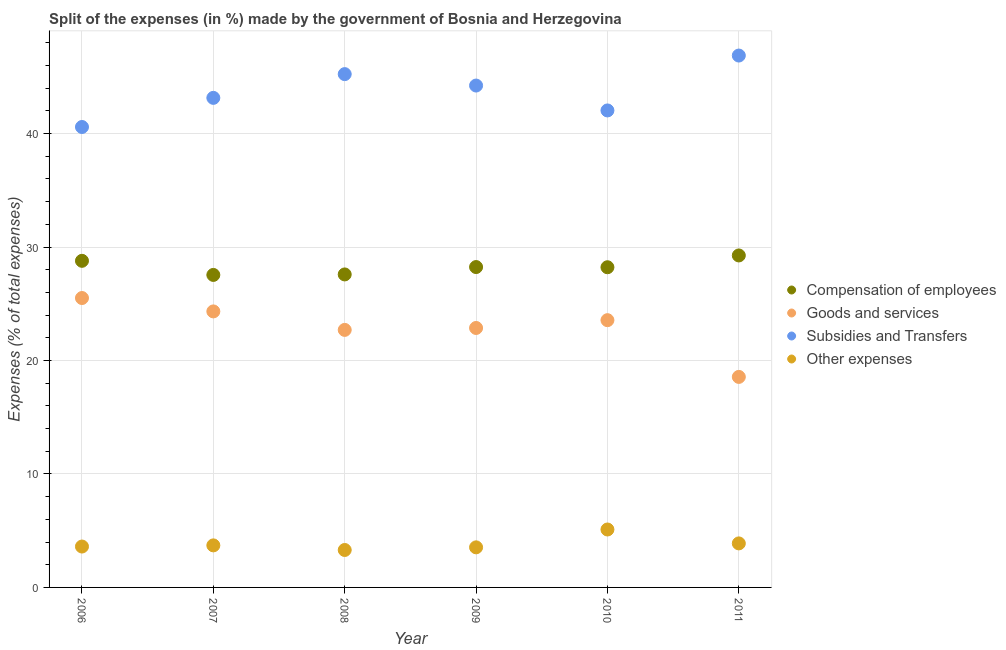How many different coloured dotlines are there?
Ensure brevity in your answer.  4. What is the percentage of amount spent on compensation of employees in 2011?
Your response must be concise. 29.26. Across all years, what is the maximum percentage of amount spent on other expenses?
Your answer should be compact. 5.11. Across all years, what is the minimum percentage of amount spent on compensation of employees?
Make the answer very short. 27.54. In which year was the percentage of amount spent on other expenses maximum?
Make the answer very short. 2010. In which year was the percentage of amount spent on subsidies minimum?
Keep it short and to the point. 2006. What is the total percentage of amount spent on compensation of employees in the graph?
Give a very brief answer. 169.61. What is the difference between the percentage of amount spent on compensation of employees in 2007 and that in 2008?
Your response must be concise. -0.04. What is the difference between the percentage of amount spent on subsidies in 2007 and the percentage of amount spent on other expenses in 2006?
Offer a terse response. 39.54. What is the average percentage of amount spent on other expenses per year?
Provide a short and direct response. 3.85. In the year 2007, what is the difference between the percentage of amount spent on compensation of employees and percentage of amount spent on goods and services?
Your response must be concise. 3.22. In how many years, is the percentage of amount spent on other expenses greater than 30 %?
Offer a terse response. 0. What is the ratio of the percentage of amount spent on compensation of employees in 2007 to that in 2010?
Your answer should be very brief. 0.98. Is the difference between the percentage of amount spent on other expenses in 2009 and 2010 greater than the difference between the percentage of amount spent on compensation of employees in 2009 and 2010?
Ensure brevity in your answer.  No. What is the difference between the highest and the second highest percentage of amount spent on other expenses?
Your response must be concise. 1.22. What is the difference between the highest and the lowest percentage of amount spent on other expenses?
Make the answer very short. 1.81. In how many years, is the percentage of amount spent on goods and services greater than the average percentage of amount spent on goods and services taken over all years?
Keep it short and to the point. 3. Is the sum of the percentage of amount spent on goods and services in 2008 and 2011 greater than the maximum percentage of amount spent on compensation of employees across all years?
Provide a short and direct response. Yes. Is it the case that in every year, the sum of the percentage of amount spent on other expenses and percentage of amount spent on compensation of employees is greater than the sum of percentage of amount spent on goods and services and percentage of amount spent on subsidies?
Provide a short and direct response. No. Does the percentage of amount spent on goods and services monotonically increase over the years?
Your answer should be very brief. No. Is the percentage of amount spent on other expenses strictly less than the percentage of amount spent on subsidies over the years?
Provide a short and direct response. Yes. Does the graph contain any zero values?
Provide a succinct answer. No. Does the graph contain grids?
Provide a succinct answer. Yes. Where does the legend appear in the graph?
Offer a terse response. Center right. How many legend labels are there?
Offer a terse response. 4. What is the title of the graph?
Keep it short and to the point. Split of the expenses (in %) made by the government of Bosnia and Herzegovina. Does "Taxes on exports" appear as one of the legend labels in the graph?
Your response must be concise. No. What is the label or title of the Y-axis?
Offer a terse response. Expenses (% of total expenses). What is the Expenses (% of total expenses) of Compensation of employees in 2006?
Your answer should be very brief. 28.78. What is the Expenses (% of total expenses) in Goods and services in 2006?
Your answer should be compact. 25.5. What is the Expenses (% of total expenses) in Subsidies and Transfers in 2006?
Give a very brief answer. 40.58. What is the Expenses (% of total expenses) in Other expenses in 2006?
Offer a very short reply. 3.6. What is the Expenses (% of total expenses) in Compensation of employees in 2007?
Your answer should be very brief. 27.54. What is the Expenses (% of total expenses) in Goods and services in 2007?
Give a very brief answer. 24.32. What is the Expenses (% of total expenses) of Subsidies and Transfers in 2007?
Your response must be concise. 43.14. What is the Expenses (% of total expenses) of Other expenses in 2007?
Provide a short and direct response. 3.71. What is the Expenses (% of total expenses) in Compensation of employees in 2008?
Give a very brief answer. 27.58. What is the Expenses (% of total expenses) of Goods and services in 2008?
Your response must be concise. 22.7. What is the Expenses (% of total expenses) in Subsidies and Transfers in 2008?
Offer a terse response. 45.24. What is the Expenses (% of total expenses) in Other expenses in 2008?
Offer a terse response. 3.3. What is the Expenses (% of total expenses) of Compensation of employees in 2009?
Provide a short and direct response. 28.23. What is the Expenses (% of total expenses) of Goods and services in 2009?
Make the answer very short. 22.87. What is the Expenses (% of total expenses) in Subsidies and Transfers in 2009?
Provide a short and direct response. 44.23. What is the Expenses (% of total expenses) of Other expenses in 2009?
Offer a terse response. 3.53. What is the Expenses (% of total expenses) of Compensation of employees in 2010?
Give a very brief answer. 28.22. What is the Expenses (% of total expenses) in Goods and services in 2010?
Your answer should be very brief. 23.55. What is the Expenses (% of total expenses) in Subsidies and Transfers in 2010?
Provide a short and direct response. 42.04. What is the Expenses (% of total expenses) of Other expenses in 2010?
Give a very brief answer. 5.11. What is the Expenses (% of total expenses) in Compensation of employees in 2011?
Keep it short and to the point. 29.26. What is the Expenses (% of total expenses) in Goods and services in 2011?
Offer a very short reply. 18.55. What is the Expenses (% of total expenses) in Subsidies and Transfers in 2011?
Keep it short and to the point. 46.87. What is the Expenses (% of total expenses) in Other expenses in 2011?
Your answer should be compact. 3.88. Across all years, what is the maximum Expenses (% of total expenses) in Compensation of employees?
Keep it short and to the point. 29.26. Across all years, what is the maximum Expenses (% of total expenses) of Goods and services?
Your answer should be very brief. 25.5. Across all years, what is the maximum Expenses (% of total expenses) of Subsidies and Transfers?
Your answer should be very brief. 46.87. Across all years, what is the maximum Expenses (% of total expenses) of Other expenses?
Keep it short and to the point. 5.11. Across all years, what is the minimum Expenses (% of total expenses) in Compensation of employees?
Offer a terse response. 27.54. Across all years, what is the minimum Expenses (% of total expenses) of Goods and services?
Provide a succinct answer. 18.55. Across all years, what is the minimum Expenses (% of total expenses) of Subsidies and Transfers?
Your answer should be compact. 40.58. Across all years, what is the minimum Expenses (% of total expenses) of Other expenses?
Provide a short and direct response. 3.3. What is the total Expenses (% of total expenses) in Compensation of employees in the graph?
Offer a terse response. 169.61. What is the total Expenses (% of total expenses) in Goods and services in the graph?
Offer a terse response. 137.49. What is the total Expenses (% of total expenses) in Subsidies and Transfers in the graph?
Provide a short and direct response. 262.1. What is the total Expenses (% of total expenses) in Other expenses in the graph?
Ensure brevity in your answer.  23.13. What is the difference between the Expenses (% of total expenses) of Compensation of employees in 2006 and that in 2007?
Your answer should be very brief. 1.24. What is the difference between the Expenses (% of total expenses) in Goods and services in 2006 and that in 2007?
Your answer should be compact. 1.18. What is the difference between the Expenses (% of total expenses) of Subsidies and Transfers in 2006 and that in 2007?
Provide a short and direct response. -2.57. What is the difference between the Expenses (% of total expenses) of Other expenses in 2006 and that in 2007?
Make the answer very short. -0.1. What is the difference between the Expenses (% of total expenses) in Compensation of employees in 2006 and that in 2008?
Provide a succinct answer. 1.2. What is the difference between the Expenses (% of total expenses) of Goods and services in 2006 and that in 2008?
Your answer should be very brief. 2.81. What is the difference between the Expenses (% of total expenses) in Subsidies and Transfers in 2006 and that in 2008?
Ensure brevity in your answer.  -4.66. What is the difference between the Expenses (% of total expenses) of Other expenses in 2006 and that in 2008?
Make the answer very short. 0.3. What is the difference between the Expenses (% of total expenses) of Compensation of employees in 2006 and that in 2009?
Keep it short and to the point. 0.55. What is the difference between the Expenses (% of total expenses) in Goods and services in 2006 and that in 2009?
Ensure brevity in your answer.  2.64. What is the difference between the Expenses (% of total expenses) in Subsidies and Transfers in 2006 and that in 2009?
Keep it short and to the point. -3.65. What is the difference between the Expenses (% of total expenses) of Other expenses in 2006 and that in 2009?
Offer a terse response. 0.07. What is the difference between the Expenses (% of total expenses) in Compensation of employees in 2006 and that in 2010?
Give a very brief answer. 0.57. What is the difference between the Expenses (% of total expenses) in Goods and services in 2006 and that in 2010?
Provide a short and direct response. 1.95. What is the difference between the Expenses (% of total expenses) in Subsidies and Transfers in 2006 and that in 2010?
Provide a succinct answer. -1.46. What is the difference between the Expenses (% of total expenses) of Other expenses in 2006 and that in 2010?
Give a very brief answer. -1.5. What is the difference between the Expenses (% of total expenses) of Compensation of employees in 2006 and that in 2011?
Give a very brief answer. -0.47. What is the difference between the Expenses (% of total expenses) of Goods and services in 2006 and that in 2011?
Ensure brevity in your answer.  6.95. What is the difference between the Expenses (% of total expenses) in Subsidies and Transfers in 2006 and that in 2011?
Your answer should be compact. -6.3. What is the difference between the Expenses (% of total expenses) of Other expenses in 2006 and that in 2011?
Provide a short and direct response. -0.28. What is the difference between the Expenses (% of total expenses) in Compensation of employees in 2007 and that in 2008?
Make the answer very short. -0.04. What is the difference between the Expenses (% of total expenses) in Goods and services in 2007 and that in 2008?
Your answer should be very brief. 1.63. What is the difference between the Expenses (% of total expenses) of Subsidies and Transfers in 2007 and that in 2008?
Make the answer very short. -2.09. What is the difference between the Expenses (% of total expenses) in Other expenses in 2007 and that in 2008?
Offer a very short reply. 0.41. What is the difference between the Expenses (% of total expenses) in Compensation of employees in 2007 and that in 2009?
Offer a very short reply. -0.69. What is the difference between the Expenses (% of total expenses) of Goods and services in 2007 and that in 2009?
Provide a short and direct response. 1.46. What is the difference between the Expenses (% of total expenses) in Subsidies and Transfers in 2007 and that in 2009?
Your answer should be compact. -1.09. What is the difference between the Expenses (% of total expenses) in Other expenses in 2007 and that in 2009?
Give a very brief answer. 0.17. What is the difference between the Expenses (% of total expenses) of Compensation of employees in 2007 and that in 2010?
Provide a succinct answer. -0.68. What is the difference between the Expenses (% of total expenses) in Goods and services in 2007 and that in 2010?
Ensure brevity in your answer.  0.77. What is the difference between the Expenses (% of total expenses) of Subsidies and Transfers in 2007 and that in 2010?
Offer a terse response. 1.11. What is the difference between the Expenses (% of total expenses) in Other expenses in 2007 and that in 2010?
Your response must be concise. -1.4. What is the difference between the Expenses (% of total expenses) in Compensation of employees in 2007 and that in 2011?
Offer a very short reply. -1.72. What is the difference between the Expenses (% of total expenses) of Goods and services in 2007 and that in 2011?
Make the answer very short. 5.77. What is the difference between the Expenses (% of total expenses) of Subsidies and Transfers in 2007 and that in 2011?
Your answer should be compact. -3.73. What is the difference between the Expenses (% of total expenses) in Other expenses in 2007 and that in 2011?
Provide a short and direct response. -0.17. What is the difference between the Expenses (% of total expenses) in Compensation of employees in 2008 and that in 2009?
Keep it short and to the point. -0.65. What is the difference between the Expenses (% of total expenses) of Goods and services in 2008 and that in 2009?
Your answer should be compact. -0.17. What is the difference between the Expenses (% of total expenses) in Subsidies and Transfers in 2008 and that in 2009?
Ensure brevity in your answer.  1.01. What is the difference between the Expenses (% of total expenses) in Other expenses in 2008 and that in 2009?
Offer a very short reply. -0.23. What is the difference between the Expenses (% of total expenses) of Compensation of employees in 2008 and that in 2010?
Offer a terse response. -0.63. What is the difference between the Expenses (% of total expenses) in Goods and services in 2008 and that in 2010?
Keep it short and to the point. -0.86. What is the difference between the Expenses (% of total expenses) in Subsidies and Transfers in 2008 and that in 2010?
Give a very brief answer. 3.2. What is the difference between the Expenses (% of total expenses) in Other expenses in 2008 and that in 2010?
Your response must be concise. -1.81. What is the difference between the Expenses (% of total expenses) of Compensation of employees in 2008 and that in 2011?
Offer a terse response. -1.67. What is the difference between the Expenses (% of total expenses) of Goods and services in 2008 and that in 2011?
Your answer should be compact. 4.14. What is the difference between the Expenses (% of total expenses) of Subsidies and Transfers in 2008 and that in 2011?
Provide a succinct answer. -1.64. What is the difference between the Expenses (% of total expenses) of Other expenses in 2008 and that in 2011?
Your response must be concise. -0.58. What is the difference between the Expenses (% of total expenses) in Compensation of employees in 2009 and that in 2010?
Provide a succinct answer. 0.02. What is the difference between the Expenses (% of total expenses) in Goods and services in 2009 and that in 2010?
Provide a succinct answer. -0.69. What is the difference between the Expenses (% of total expenses) of Subsidies and Transfers in 2009 and that in 2010?
Your answer should be compact. 2.19. What is the difference between the Expenses (% of total expenses) in Other expenses in 2009 and that in 2010?
Your response must be concise. -1.57. What is the difference between the Expenses (% of total expenses) of Compensation of employees in 2009 and that in 2011?
Provide a short and direct response. -1.02. What is the difference between the Expenses (% of total expenses) of Goods and services in 2009 and that in 2011?
Your answer should be very brief. 4.31. What is the difference between the Expenses (% of total expenses) of Subsidies and Transfers in 2009 and that in 2011?
Offer a very short reply. -2.64. What is the difference between the Expenses (% of total expenses) in Other expenses in 2009 and that in 2011?
Your response must be concise. -0.35. What is the difference between the Expenses (% of total expenses) in Compensation of employees in 2010 and that in 2011?
Provide a short and direct response. -1.04. What is the difference between the Expenses (% of total expenses) of Goods and services in 2010 and that in 2011?
Provide a succinct answer. 5. What is the difference between the Expenses (% of total expenses) of Subsidies and Transfers in 2010 and that in 2011?
Your answer should be very brief. -4.84. What is the difference between the Expenses (% of total expenses) in Other expenses in 2010 and that in 2011?
Make the answer very short. 1.22. What is the difference between the Expenses (% of total expenses) in Compensation of employees in 2006 and the Expenses (% of total expenses) in Goods and services in 2007?
Provide a succinct answer. 4.46. What is the difference between the Expenses (% of total expenses) of Compensation of employees in 2006 and the Expenses (% of total expenses) of Subsidies and Transfers in 2007?
Keep it short and to the point. -14.36. What is the difference between the Expenses (% of total expenses) of Compensation of employees in 2006 and the Expenses (% of total expenses) of Other expenses in 2007?
Your response must be concise. 25.08. What is the difference between the Expenses (% of total expenses) in Goods and services in 2006 and the Expenses (% of total expenses) in Subsidies and Transfers in 2007?
Provide a succinct answer. -17.64. What is the difference between the Expenses (% of total expenses) in Goods and services in 2006 and the Expenses (% of total expenses) in Other expenses in 2007?
Offer a very short reply. 21.8. What is the difference between the Expenses (% of total expenses) of Subsidies and Transfers in 2006 and the Expenses (% of total expenses) of Other expenses in 2007?
Offer a very short reply. 36.87. What is the difference between the Expenses (% of total expenses) of Compensation of employees in 2006 and the Expenses (% of total expenses) of Goods and services in 2008?
Provide a short and direct response. 6.09. What is the difference between the Expenses (% of total expenses) of Compensation of employees in 2006 and the Expenses (% of total expenses) of Subsidies and Transfers in 2008?
Offer a very short reply. -16.45. What is the difference between the Expenses (% of total expenses) in Compensation of employees in 2006 and the Expenses (% of total expenses) in Other expenses in 2008?
Provide a succinct answer. 25.48. What is the difference between the Expenses (% of total expenses) of Goods and services in 2006 and the Expenses (% of total expenses) of Subsidies and Transfers in 2008?
Give a very brief answer. -19.73. What is the difference between the Expenses (% of total expenses) in Goods and services in 2006 and the Expenses (% of total expenses) in Other expenses in 2008?
Give a very brief answer. 22.2. What is the difference between the Expenses (% of total expenses) in Subsidies and Transfers in 2006 and the Expenses (% of total expenses) in Other expenses in 2008?
Your answer should be compact. 37.28. What is the difference between the Expenses (% of total expenses) of Compensation of employees in 2006 and the Expenses (% of total expenses) of Goods and services in 2009?
Ensure brevity in your answer.  5.92. What is the difference between the Expenses (% of total expenses) of Compensation of employees in 2006 and the Expenses (% of total expenses) of Subsidies and Transfers in 2009?
Your answer should be compact. -15.45. What is the difference between the Expenses (% of total expenses) in Compensation of employees in 2006 and the Expenses (% of total expenses) in Other expenses in 2009?
Keep it short and to the point. 25.25. What is the difference between the Expenses (% of total expenses) in Goods and services in 2006 and the Expenses (% of total expenses) in Subsidies and Transfers in 2009?
Your response must be concise. -18.73. What is the difference between the Expenses (% of total expenses) of Goods and services in 2006 and the Expenses (% of total expenses) of Other expenses in 2009?
Provide a succinct answer. 21.97. What is the difference between the Expenses (% of total expenses) of Subsidies and Transfers in 2006 and the Expenses (% of total expenses) of Other expenses in 2009?
Offer a very short reply. 37.05. What is the difference between the Expenses (% of total expenses) of Compensation of employees in 2006 and the Expenses (% of total expenses) of Goods and services in 2010?
Give a very brief answer. 5.23. What is the difference between the Expenses (% of total expenses) of Compensation of employees in 2006 and the Expenses (% of total expenses) of Subsidies and Transfers in 2010?
Provide a short and direct response. -13.25. What is the difference between the Expenses (% of total expenses) of Compensation of employees in 2006 and the Expenses (% of total expenses) of Other expenses in 2010?
Offer a very short reply. 23.68. What is the difference between the Expenses (% of total expenses) of Goods and services in 2006 and the Expenses (% of total expenses) of Subsidies and Transfers in 2010?
Your answer should be very brief. -16.53. What is the difference between the Expenses (% of total expenses) in Goods and services in 2006 and the Expenses (% of total expenses) in Other expenses in 2010?
Your answer should be compact. 20.4. What is the difference between the Expenses (% of total expenses) in Subsidies and Transfers in 2006 and the Expenses (% of total expenses) in Other expenses in 2010?
Ensure brevity in your answer.  35.47. What is the difference between the Expenses (% of total expenses) in Compensation of employees in 2006 and the Expenses (% of total expenses) in Goods and services in 2011?
Give a very brief answer. 10.23. What is the difference between the Expenses (% of total expenses) of Compensation of employees in 2006 and the Expenses (% of total expenses) of Subsidies and Transfers in 2011?
Offer a very short reply. -18.09. What is the difference between the Expenses (% of total expenses) in Compensation of employees in 2006 and the Expenses (% of total expenses) in Other expenses in 2011?
Your response must be concise. 24.9. What is the difference between the Expenses (% of total expenses) of Goods and services in 2006 and the Expenses (% of total expenses) of Subsidies and Transfers in 2011?
Give a very brief answer. -21.37. What is the difference between the Expenses (% of total expenses) of Goods and services in 2006 and the Expenses (% of total expenses) of Other expenses in 2011?
Ensure brevity in your answer.  21.62. What is the difference between the Expenses (% of total expenses) of Subsidies and Transfers in 2006 and the Expenses (% of total expenses) of Other expenses in 2011?
Give a very brief answer. 36.7. What is the difference between the Expenses (% of total expenses) of Compensation of employees in 2007 and the Expenses (% of total expenses) of Goods and services in 2008?
Provide a succinct answer. 4.84. What is the difference between the Expenses (% of total expenses) in Compensation of employees in 2007 and the Expenses (% of total expenses) in Subsidies and Transfers in 2008?
Ensure brevity in your answer.  -17.7. What is the difference between the Expenses (% of total expenses) of Compensation of employees in 2007 and the Expenses (% of total expenses) of Other expenses in 2008?
Give a very brief answer. 24.24. What is the difference between the Expenses (% of total expenses) of Goods and services in 2007 and the Expenses (% of total expenses) of Subsidies and Transfers in 2008?
Ensure brevity in your answer.  -20.91. What is the difference between the Expenses (% of total expenses) of Goods and services in 2007 and the Expenses (% of total expenses) of Other expenses in 2008?
Ensure brevity in your answer.  21.03. What is the difference between the Expenses (% of total expenses) of Subsidies and Transfers in 2007 and the Expenses (% of total expenses) of Other expenses in 2008?
Your answer should be very brief. 39.84. What is the difference between the Expenses (% of total expenses) of Compensation of employees in 2007 and the Expenses (% of total expenses) of Goods and services in 2009?
Give a very brief answer. 4.67. What is the difference between the Expenses (% of total expenses) in Compensation of employees in 2007 and the Expenses (% of total expenses) in Subsidies and Transfers in 2009?
Ensure brevity in your answer.  -16.69. What is the difference between the Expenses (% of total expenses) of Compensation of employees in 2007 and the Expenses (% of total expenses) of Other expenses in 2009?
Offer a very short reply. 24.01. What is the difference between the Expenses (% of total expenses) in Goods and services in 2007 and the Expenses (% of total expenses) in Subsidies and Transfers in 2009?
Your answer should be very brief. -19.9. What is the difference between the Expenses (% of total expenses) of Goods and services in 2007 and the Expenses (% of total expenses) of Other expenses in 2009?
Offer a terse response. 20.79. What is the difference between the Expenses (% of total expenses) of Subsidies and Transfers in 2007 and the Expenses (% of total expenses) of Other expenses in 2009?
Give a very brief answer. 39.61. What is the difference between the Expenses (% of total expenses) in Compensation of employees in 2007 and the Expenses (% of total expenses) in Goods and services in 2010?
Provide a short and direct response. 3.99. What is the difference between the Expenses (% of total expenses) of Compensation of employees in 2007 and the Expenses (% of total expenses) of Subsidies and Transfers in 2010?
Ensure brevity in your answer.  -14.5. What is the difference between the Expenses (% of total expenses) in Compensation of employees in 2007 and the Expenses (% of total expenses) in Other expenses in 2010?
Keep it short and to the point. 22.43. What is the difference between the Expenses (% of total expenses) of Goods and services in 2007 and the Expenses (% of total expenses) of Subsidies and Transfers in 2010?
Your answer should be compact. -17.71. What is the difference between the Expenses (% of total expenses) of Goods and services in 2007 and the Expenses (% of total expenses) of Other expenses in 2010?
Offer a terse response. 19.22. What is the difference between the Expenses (% of total expenses) of Subsidies and Transfers in 2007 and the Expenses (% of total expenses) of Other expenses in 2010?
Offer a terse response. 38.04. What is the difference between the Expenses (% of total expenses) of Compensation of employees in 2007 and the Expenses (% of total expenses) of Goods and services in 2011?
Make the answer very short. 8.99. What is the difference between the Expenses (% of total expenses) of Compensation of employees in 2007 and the Expenses (% of total expenses) of Subsidies and Transfers in 2011?
Your answer should be very brief. -19.33. What is the difference between the Expenses (% of total expenses) in Compensation of employees in 2007 and the Expenses (% of total expenses) in Other expenses in 2011?
Ensure brevity in your answer.  23.66. What is the difference between the Expenses (% of total expenses) of Goods and services in 2007 and the Expenses (% of total expenses) of Subsidies and Transfers in 2011?
Your answer should be compact. -22.55. What is the difference between the Expenses (% of total expenses) of Goods and services in 2007 and the Expenses (% of total expenses) of Other expenses in 2011?
Your response must be concise. 20.44. What is the difference between the Expenses (% of total expenses) of Subsidies and Transfers in 2007 and the Expenses (% of total expenses) of Other expenses in 2011?
Make the answer very short. 39.26. What is the difference between the Expenses (% of total expenses) of Compensation of employees in 2008 and the Expenses (% of total expenses) of Goods and services in 2009?
Provide a short and direct response. 4.72. What is the difference between the Expenses (% of total expenses) in Compensation of employees in 2008 and the Expenses (% of total expenses) in Subsidies and Transfers in 2009?
Ensure brevity in your answer.  -16.65. What is the difference between the Expenses (% of total expenses) of Compensation of employees in 2008 and the Expenses (% of total expenses) of Other expenses in 2009?
Your answer should be very brief. 24.05. What is the difference between the Expenses (% of total expenses) in Goods and services in 2008 and the Expenses (% of total expenses) in Subsidies and Transfers in 2009?
Your answer should be very brief. -21.53. What is the difference between the Expenses (% of total expenses) in Goods and services in 2008 and the Expenses (% of total expenses) in Other expenses in 2009?
Provide a short and direct response. 19.16. What is the difference between the Expenses (% of total expenses) of Subsidies and Transfers in 2008 and the Expenses (% of total expenses) of Other expenses in 2009?
Offer a terse response. 41.7. What is the difference between the Expenses (% of total expenses) of Compensation of employees in 2008 and the Expenses (% of total expenses) of Goods and services in 2010?
Ensure brevity in your answer.  4.03. What is the difference between the Expenses (% of total expenses) in Compensation of employees in 2008 and the Expenses (% of total expenses) in Subsidies and Transfers in 2010?
Your answer should be compact. -14.45. What is the difference between the Expenses (% of total expenses) in Compensation of employees in 2008 and the Expenses (% of total expenses) in Other expenses in 2010?
Your answer should be compact. 22.48. What is the difference between the Expenses (% of total expenses) of Goods and services in 2008 and the Expenses (% of total expenses) of Subsidies and Transfers in 2010?
Provide a short and direct response. -19.34. What is the difference between the Expenses (% of total expenses) in Goods and services in 2008 and the Expenses (% of total expenses) in Other expenses in 2010?
Your answer should be compact. 17.59. What is the difference between the Expenses (% of total expenses) of Subsidies and Transfers in 2008 and the Expenses (% of total expenses) of Other expenses in 2010?
Your response must be concise. 40.13. What is the difference between the Expenses (% of total expenses) in Compensation of employees in 2008 and the Expenses (% of total expenses) in Goods and services in 2011?
Offer a very short reply. 9.03. What is the difference between the Expenses (% of total expenses) in Compensation of employees in 2008 and the Expenses (% of total expenses) in Subsidies and Transfers in 2011?
Provide a succinct answer. -19.29. What is the difference between the Expenses (% of total expenses) of Compensation of employees in 2008 and the Expenses (% of total expenses) of Other expenses in 2011?
Offer a very short reply. 23.7. What is the difference between the Expenses (% of total expenses) in Goods and services in 2008 and the Expenses (% of total expenses) in Subsidies and Transfers in 2011?
Give a very brief answer. -24.18. What is the difference between the Expenses (% of total expenses) in Goods and services in 2008 and the Expenses (% of total expenses) in Other expenses in 2011?
Keep it short and to the point. 18.81. What is the difference between the Expenses (% of total expenses) of Subsidies and Transfers in 2008 and the Expenses (% of total expenses) of Other expenses in 2011?
Make the answer very short. 41.36. What is the difference between the Expenses (% of total expenses) in Compensation of employees in 2009 and the Expenses (% of total expenses) in Goods and services in 2010?
Offer a very short reply. 4.68. What is the difference between the Expenses (% of total expenses) in Compensation of employees in 2009 and the Expenses (% of total expenses) in Subsidies and Transfers in 2010?
Keep it short and to the point. -13.8. What is the difference between the Expenses (% of total expenses) of Compensation of employees in 2009 and the Expenses (% of total expenses) of Other expenses in 2010?
Make the answer very short. 23.13. What is the difference between the Expenses (% of total expenses) of Goods and services in 2009 and the Expenses (% of total expenses) of Subsidies and Transfers in 2010?
Your answer should be compact. -19.17. What is the difference between the Expenses (% of total expenses) in Goods and services in 2009 and the Expenses (% of total expenses) in Other expenses in 2010?
Your answer should be compact. 17.76. What is the difference between the Expenses (% of total expenses) of Subsidies and Transfers in 2009 and the Expenses (% of total expenses) of Other expenses in 2010?
Make the answer very short. 39.12. What is the difference between the Expenses (% of total expenses) in Compensation of employees in 2009 and the Expenses (% of total expenses) in Goods and services in 2011?
Make the answer very short. 9.68. What is the difference between the Expenses (% of total expenses) in Compensation of employees in 2009 and the Expenses (% of total expenses) in Subsidies and Transfers in 2011?
Make the answer very short. -18.64. What is the difference between the Expenses (% of total expenses) of Compensation of employees in 2009 and the Expenses (% of total expenses) of Other expenses in 2011?
Your answer should be very brief. 24.35. What is the difference between the Expenses (% of total expenses) of Goods and services in 2009 and the Expenses (% of total expenses) of Subsidies and Transfers in 2011?
Offer a terse response. -24.01. What is the difference between the Expenses (% of total expenses) of Goods and services in 2009 and the Expenses (% of total expenses) of Other expenses in 2011?
Provide a succinct answer. 18.98. What is the difference between the Expenses (% of total expenses) of Subsidies and Transfers in 2009 and the Expenses (% of total expenses) of Other expenses in 2011?
Provide a succinct answer. 40.35. What is the difference between the Expenses (% of total expenses) of Compensation of employees in 2010 and the Expenses (% of total expenses) of Goods and services in 2011?
Provide a short and direct response. 9.66. What is the difference between the Expenses (% of total expenses) of Compensation of employees in 2010 and the Expenses (% of total expenses) of Subsidies and Transfers in 2011?
Your response must be concise. -18.66. What is the difference between the Expenses (% of total expenses) of Compensation of employees in 2010 and the Expenses (% of total expenses) of Other expenses in 2011?
Make the answer very short. 24.34. What is the difference between the Expenses (% of total expenses) of Goods and services in 2010 and the Expenses (% of total expenses) of Subsidies and Transfers in 2011?
Your response must be concise. -23.32. What is the difference between the Expenses (% of total expenses) of Goods and services in 2010 and the Expenses (% of total expenses) of Other expenses in 2011?
Offer a very short reply. 19.67. What is the difference between the Expenses (% of total expenses) in Subsidies and Transfers in 2010 and the Expenses (% of total expenses) in Other expenses in 2011?
Provide a short and direct response. 38.16. What is the average Expenses (% of total expenses) of Compensation of employees per year?
Ensure brevity in your answer.  28.27. What is the average Expenses (% of total expenses) of Goods and services per year?
Your answer should be very brief. 22.92. What is the average Expenses (% of total expenses) in Subsidies and Transfers per year?
Your response must be concise. 43.68. What is the average Expenses (% of total expenses) of Other expenses per year?
Offer a terse response. 3.85. In the year 2006, what is the difference between the Expenses (% of total expenses) in Compensation of employees and Expenses (% of total expenses) in Goods and services?
Make the answer very short. 3.28. In the year 2006, what is the difference between the Expenses (% of total expenses) of Compensation of employees and Expenses (% of total expenses) of Subsidies and Transfers?
Your response must be concise. -11.79. In the year 2006, what is the difference between the Expenses (% of total expenses) of Compensation of employees and Expenses (% of total expenses) of Other expenses?
Ensure brevity in your answer.  25.18. In the year 2006, what is the difference between the Expenses (% of total expenses) in Goods and services and Expenses (% of total expenses) in Subsidies and Transfers?
Provide a short and direct response. -15.07. In the year 2006, what is the difference between the Expenses (% of total expenses) of Goods and services and Expenses (% of total expenses) of Other expenses?
Offer a very short reply. 21.9. In the year 2006, what is the difference between the Expenses (% of total expenses) in Subsidies and Transfers and Expenses (% of total expenses) in Other expenses?
Offer a terse response. 36.97. In the year 2007, what is the difference between the Expenses (% of total expenses) of Compensation of employees and Expenses (% of total expenses) of Goods and services?
Offer a very short reply. 3.22. In the year 2007, what is the difference between the Expenses (% of total expenses) of Compensation of employees and Expenses (% of total expenses) of Subsidies and Transfers?
Give a very brief answer. -15.6. In the year 2007, what is the difference between the Expenses (% of total expenses) of Compensation of employees and Expenses (% of total expenses) of Other expenses?
Ensure brevity in your answer.  23.83. In the year 2007, what is the difference between the Expenses (% of total expenses) of Goods and services and Expenses (% of total expenses) of Subsidies and Transfers?
Ensure brevity in your answer.  -18.82. In the year 2007, what is the difference between the Expenses (% of total expenses) of Goods and services and Expenses (% of total expenses) of Other expenses?
Your response must be concise. 20.62. In the year 2007, what is the difference between the Expenses (% of total expenses) of Subsidies and Transfers and Expenses (% of total expenses) of Other expenses?
Offer a very short reply. 39.44. In the year 2008, what is the difference between the Expenses (% of total expenses) in Compensation of employees and Expenses (% of total expenses) in Goods and services?
Offer a very short reply. 4.89. In the year 2008, what is the difference between the Expenses (% of total expenses) of Compensation of employees and Expenses (% of total expenses) of Subsidies and Transfers?
Give a very brief answer. -17.65. In the year 2008, what is the difference between the Expenses (% of total expenses) of Compensation of employees and Expenses (% of total expenses) of Other expenses?
Make the answer very short. 24.28. In the year 2008, what is the difference between the Expenses (% of total expenses) in Goods and services and Expenses (% of total expenses) in Subsidies and Transfers?
Your answer should be very brief. -22.54. In the year 2008, what is the difference between the Expenses (% of total expenses) in Goods and services and Expenses (% of total expenses) in Other expenses?
Your answer should be very brief. 19.4. In the year 2008, what is the difference between the Expenses (% of total expenses) in Subsidies and Transfers and Expenses (% of total expenses) in Other expenses?
Make the answer very short. 41.94. In the year 2009, what is the difference between the Expenses (% of total expenses) in Compensation of employees and Expenses (% of total expenses) in Goods and services?
Provide a succinct answer. 5.37. In the year 2009, what is the difference between the Expenses (% of total expenses) in Compensation of employees and Expenses (% of total expenses) in Subsidies and Transfers?
Your response must be concise. -16. In the year 2009, what is the difference between the Expenses (% of total expenses) in Compensation of employees and Expenses (% of total expenses) in Other expenses?
Offer a terse response. 24.7. In the year 2009, what is the difference between the Expenses (% of total expenses) of Goods and services and Expenses (% of total expenses) of Subsidies and Transfers?
Make the answer very short. -21.36. In the year 2009, what is the difference between the Expenses (% of total expenses) in Goods and services and Expenses (% of total expenses) in Other expenses?
Give a very brief answer. 19.33. In the year 2009, what is the difference between the Expenses (% of total expenses) in Subsidies and Transfers and Expenses (% of total expenses) in Other expenses?
Make the answer very short. 40.7. In the year 2010, what is the difference between the Expenses (% of total expenses) in Compensation of employees and Expenses (% of total expenses) in Goods and services?
Provide a short and direct response. 4.66. In the year 2010, what is the difference between the Expenses (% of total expenses) of Compensation of employees and Expenses (% of total expenses) of Subsidies and Transfers?
Give a very brief answer. -13.82. In the year 2010, what is the difference between the Expenses (% of total expenses) in Compensation of employees and Expenses (% of total expenses) in Other expenses?
Give a very brief answer. 23.11. In the year 2010, what is the difference between the Expenses (% of total expenses) of Goods and services and Expenses (% of total expenses) of Subsidies and Transfers?
Provide a short and direct response. -18.48. In the year 2010, what is the difference between the Expenses (% of total expenses) in Goods and services and Expenses (% of total expenses) in Other expenses?
Offer a terse response. 18.45. In the year 2010, what is the difference between the Expenses (% of total expenses) of Subsidies and Transfers and Expenses (% of total expenses) of Other expenses?
Your answer should be compact. 36.93. In the year 2011, what is the difference between the Expenses (% of total expenses) in Compensation of employees and Expenses (% of total expenses) in Goods and services?
Your answer should be compact. 10.7. In the year 2011, what is the difference between the Expenses (% of total expenses) in Compensation of employees and Expenses (% of total expenses) in Subsidies and Transfers?
Ensure brevity in your answer.  -17.62. In the year 2011, what is the difference between the Expenses (% of total expenses) of Compensation of employees and Expenses (% of total expenses) of Other expenses?
Offer a terse response. 25.38. In the year 2011, what is the difference between the Expenses (% of total expenses) in Goods and services and Expenses (% of total expenses) in Subsidies and Transfers?
Keep it short and to the point. -28.32. In the year 2011, what is the difference between the Expenses (% of total expenses) in Goods and services and Expenses (% of total expenses) in Other expenses?
Provide a succinct answer. 14.67. In the year 2011, what is the difference between the Expenses (% of total expenses) of Subsidies and Transfers and Expenses (% of total expenses) of Other expenses?
Your response must be concise. 42.99. What is the ratio of the Expenses (% of total expenses) in Compensation of employees in 2006 to that in 2007?
Your response must be concise. 1.05. What is the ratio of the Expenses (% of total expenses) in Goods and services in 2006 to that in 2007?
Your answer should be compact. 1.05. What is the ratio of the Expenses (% of total expenses) in Subsidies and Transfers in 2006 to that in 2007?
Make the answer very short. 0.94. What is the ratio of the Expenses (% of total expenses) in Other expenses in 2006 to that in 2007?
Your answer should be compact. 0.97. What is the ratio of the Expenses (% of total expenses) in Compensation of employees in 2006 to that in 2008?
Make the answer very short. 1.04. What is the ratio of the Expenses (% of total expenses) in Goods and services in 2006 to that in 2008?
Give a very brief answer. 1.12. What is the ratio of the Expenses (% of total expenses) in Subsidies and Transfers in 2006 to that in 2008?
Your answer should be very brief. 0.9. What is the ratio of the Expenses (% of total expenses) of Other expenses in 2006 to that in 2008?
Provide a short and direct response. 1.09. What is the ratio of the Expenses (% of total expenses) in Compensation of employees in 2006 to that in 2009?
Your answer should be compact. 1.02. What is the ratio of the Expenses (% of total expenses) in Goods and services in 2006 to that in 2009?
Give a very brief answer. 1.12. What is the ratio of the Expenses (% of total expenses) in Subsidies and Transfers in 2006 to that in 2009?
Your response must be concise. 0.92. What is the ratio of the Expenses (% of total expenses) of Other expenses in 2006 to that in 2009?
Your answer should be very brief. 1.02. What is the ratio of the Expenses (% of total expenses) of Compensation of employees in 2006 to that in 2010?
Your response must be concise. 1.02. What is the ratio of the Expenses (% of total expenses) of Goods and services in 2006 to that in 2010?
Make the answer very short. 1.08. What is the ratio of the Expenses (% of total expenses) of Subsidies and Transfers in 2006 to that in 2010?
Offer a very short reply. 0.97. What is the ratio of the Expenses (% of total expenses) of Other expenses in 2006 to that in 2010?
Provide a succinct answer. 0.71. What is the ratio of the Expenses (% of total expenses) in Compensation of employees in 2006 to that in 2011?
Provide a succinct answer. 0.98. What is the ratio of the Expenses (% of total expenses) of Goods and services in 2006 to that in 2011?
Make the answer very short. 1.37. What is the ratio of the Expenses (% of total expenses) in Subsidies and Transfers in 2006 to that in 2011?
Keep it short and to the point. 0.87. What is the ratio of the Expenses (% of total expenses) in Other expenses in 2006 to that in 2011?
Your answer should be very brief. 0.93. What is the ratio of the Expenses (% of total expenses) of Compensation of employees in 2007 to that in 2008?
Ensure brevity in your answer.  1. What is the ratio of the Expenses (% of total expenses) in Goods and services in 2007 to that in 2008?
Provide a short and direct response. 1.07. What is the ratio of the Expenses (% of total expenses) in Subsidies and Transfers in 2007 to that in 2008?
Your answer should be very brief. 0.95. What is the ratio of the Expenses (% of total expenses) in Other expenses in 2007 to that in 2008?
Your response must be concise. 1.12. What is the ratio of the Expenses (% of total expenses) of Compensation of employees in 2007 to that in 2009?
Your response must be concise. 0.98. What is the ratio of the Expenses (% of total expenses) in Goods and services in 2007 to that in 2009?
Your answer should be very brief. 1.06. What is the ratio of the Expenses (% of total expenses) in Subsidies and Transfers in 2007 to that in 2009?
Give a very brief answer. 0.98. What is the ratio of the Expenses (% of total expenses) of Other expenses in 2007 to that in 2009?
Your response must be concise. 1.05. What is the ratio of the Expenses (% of total expenses) in Goods and services in 2007 to that in 2010?
Offer a terse response. 1.03. What is the ratio of the Expenses (% of total expenses) of Subsidies and Transfers in 2007 to that in 2010?
Your response must be concise. 1.03. What is the ratio of the Expenses (% of total expenses) in Other expenses in 2007 to that in 2010?
Provide a succinct answer. 0.73. What is the ratio of the Expenses (% of total expenses) in Compensation of employees in 2007 to that in 2011?
Provide a succinct answer. 0.94. What is the ratio of the Expenses (% of total expenses) in Goods and services in 2007 to that in 2011?
Your answer should be compact. 1.31. What is the ratio of the Expenses (% of total expenses) of Subsidies and Transfers in 2007 to that in 2011?
Your answer should be compact. 0.92. What is the ratio of the Expenses (% of total expenses) of Other expenses in 2007 to that in 2011?
Make the answer very short. 0.95. What is the ratio of the Expenses (% of total expenses) in Goods and services in 2008 to that in 2009?
Provide a succinct answer. 0.99. What is the ratio of the Expenses (% of total expenses) in Subsidies and Transfers in 2008 to that in 2009?
Provide a short and direct response. 1.02. What is the ratio of the Expenses (% of total expenses) of Other expenses in 2008 to that in 2009?
Provide a succinct answer. 0.93. What is the ratio of the Expenses (% of total expenses) of Compensation of employees in 2008 to that in 2010?
Keep it short and to the point. 0.98. What is the ratio of the Expenses (% of total expenses) of Goods and services in 2008 to that in 2010?
Ensure brevity in your answer.  0.96. What is the ratio of the Expenses (% of total expenses) of Subsidies and Transfers in 2008 to that in 2010?
Provide a short and direct response. 1.08. What is the ratio of the Expenses (% of total expenses) of Other expenses in 2008 to that in 2010?
Offer a terse response. 0.65. What is the ratio of the Expenses (% of total expenses) of Compensation of employees in 2008 to that in 2011?
Give a very brief answer. 0.94. What is the ratio of the Expenses (% of total expenses) in Goods and services in 2008 to that in 2011?
Your response must be concise. 1.22. What is the ratio of the Expenses (% of total expenses) of Subsidies and Transfers in 2008 to that in 2011?
Offer a terse response. 0.97. What is the ratio of the Expenses (% of total expenses) in Other expenses in 2008 to that in 2011?
Offer a terse response. 0.85. What is the ratio of the Expenses (% of total expenses) in Compensation of employees in 2009 to that in 2010?
Ensure brevity in your answer.  1. What is the ratio of the Expenses (% of total expenses) of Goods and services in 2009 to that in 2010?
Make the answer very short. 0.97. What is the ratio of the Expenses (% of total expenses) of Subsidies and Transfers in 2009 to that in 2010?
Your answer should be very brief. 1.05. What is the ratio of the Expenses (% of total expenses) of Other expenses in 2009 to that in 2010?
Offer a terse response. 0.69. What is the ratio of the Expenses (% of total expenses) of Compensation of employees in 2009 to that in 2011?
Your answer should be compact. 0.97. What is the ratio of the Expenses (% of total expenses) of Goods and services in 2009 to that in 2011?
Give a very brief answer. 1.23. What is the ratio of the Expenses (% of total expenses) in Subsidies and Transfers in 2009 to that in 2011?
Provide a succinct answer. 0.94. What is the ratio of the Expenses (% of total expenses) in Other expenses in 2009 to that in 2011?
Give a very brief answer. 0.91. What is the ratio of the Expenses (% of total expenses) of Compensation of employees in 2010 to that in 2011?
Offer a very short reply. 0.96. What is the ratio of the Expenses (% of total expenses) in Goods and services in 2010 to that in 2011?
Your answer should be very brief. 1.27. What is the ratio of the Expenses (% of total expenses) of Subsidies and Transfers in 2010 to that in 2011?
Your response must be concise. 0.9. What is the ratio of the Expenses (% of total expenses) of Other expenses in 2010 to that in 2011?
Provide a short and direct response. 1.32. What is the difference between the highest and the second highest Expenses (% of total expenses) of Compensation of employees?
Make the answer very short. 0.47. What is the difference between the highest and the second highest Expenses (% of total expenses) of Goods and services?
Your answer should be very brief. 1.18. What is the difference between the highest and the second highest Expenses (% of total expenses) of Subsidies and Transfers?
Provide a short and direct response. 1.64. What is the difference between the highest and the second highest Expenses (% of total expenses) of Other expenses?
Offer a terse response. 1.22. What is the difference between the highest and the lowest Expenses (% of total expenses) of Compensation of employees?
Keep it short and to the point. 1.72. What is the difference between the highest and the lowest Expenses (% of total expenses) in Goods and services?
Offer a terse response. 6.95. What is the difference between the highest and the lowest Expenses (% of total expenses) in Subsidies and Transfers?
Keep it short and to the point. 6.3. What is the difference between the highest and the lowest Expenses (% of total expenses) of Other expenses?
Give a very brief answer. 1.81. 